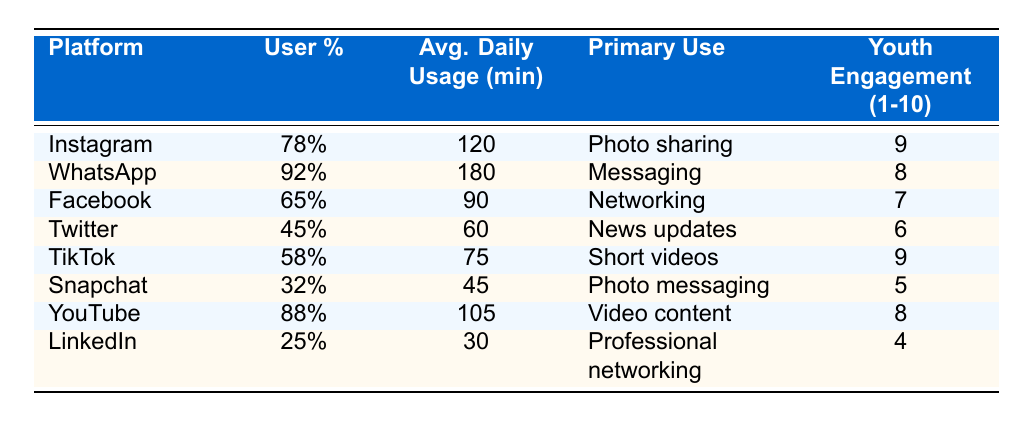What is the platform with the highest user percentage among Nigerian youth? The table shows that WhatsApp has the highest user percentage at 92%.
Answer: WhatsApp What is the average daily usage time for TikTok users? According to the table, TikTok users have an average daily usage time of 75 minutes.
Answer: 75 minutes Which platform is primarily used for video content? The table indicates that YouTube is the platform primarily used for video content.
Answer: YouTube How many platforms have a youth engagement score of 8 or higher? From the table, Instagram (9), WhatsApp (8), YouTube (8), and TikTok (9) have scores of 8 or higher, totaling four platforms.
Answer: Four platforms Is Snapchat more popular than LinkedIn based on user percentage? Comparing their user percentages, Snapchat at 32% is indeed more popular than LinkedIn, which has 25%.
Answer: Yes What is the total average daily usage time of platforms that have a user percentage above 70%? The platforms above 70% are Instagram (120), WhatsApp (180), and YouTube (105). Adding these gives 120 + 180 + 105 = 405 minutes.
Answer: 405 minutes Which social media platform has the lowest average daily usage time? The table shows that LinkedIn has the lowest average daily usage time of 30 minutes.
Answer: LinkedIn How does the user percentage of Instagram compare to that of Facebook? Instagram has a user percentage of 78%, while Facebook has 65%, meaning Instagram is more popular.
Answer: Instagram is more popular What is the difference in youth engagement scores between WhatsApp and Twitter? WhatsApp has a youth engagement score of 8, while Twitter's score is 6. The difference is 8 - 6 = 2.
Answer: 2 Which platforms are primarily used for messaging and short videos? WhatsApp is used for messaging, and TikTok is used for short videos, as indicated in the table.
Answer: WhatsApp and TikTok 